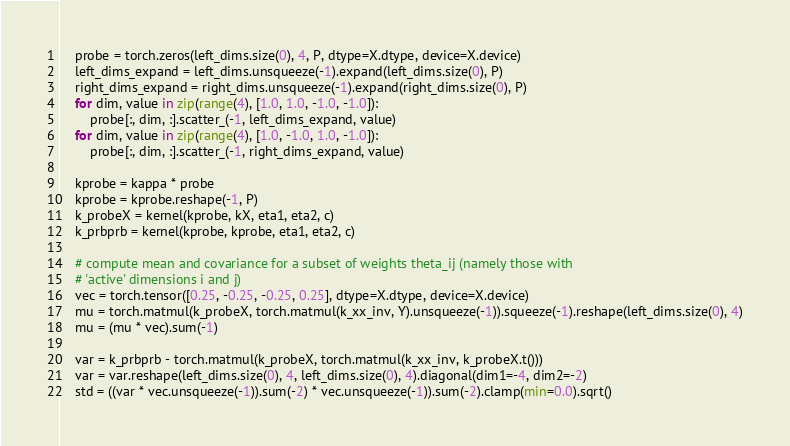Convert code to text. <code><loc_0><loc_0><loc_500><loc_500><_Python_>    probe = torch.zeros(left_dims.size(0), 4, P, dtype=X.dtype, device=X.device)
    left_dims_expand = left_dims.unsqueeze(-1).expand(left_dims.size(0), P)
    right_dims_expand = right_dims.unsqueeze(-1).expand(right_dims.size(0), P)
    for dim, value in zip(range(4), [1.0, 1.0, -1.0, -1.0]):
        probe[:, dim, :].scatter_(-1, left_dims_expand, value)
    for dim, value in zip(range(4), [1.0, -1.0, 1.0, -1.0]):
        probe[:, dim, :].scatter_(-1, right_dims_expand, value)

    kprobe = kappa * probe
    kprobe = kprobe.reshape(-1, P)
    k_probeX = kernel(kprobe, kX, eta1, eta2, c)
    k_prbprb = kernel(kprobe, kprobe, eta1, eta2, c)

    # compute mean and covariance for a subset of weights theta_ij (namely those with
    # 'active' dimensions i and j)
    vec = torch.tensor([0.25, -0.25, -0.25, 0.25], dtype=X.dtype, device=X.device)
    mu = torch.matmul(k_probeX, torch.matmul(k_xx_inv, Y).unsqueeze(-1)).squeeze(-1).reshape(left_dims.size(0), 4)
    mu = (mu * vec).sum(-1)

    var = k_prbprb - torch.matmul(k_probeX, torch.matmul(k_xx_inv, k_probeX.t()))
    var = var.reshape(left_dims.size(0), 4, left_dims.size(0), 4).diagonal(dim1=-4, dim2=-2)
    std = ((var * vec.unsqueeze(-1)).sum(-2) * vec.unsqueeze(-1)).sum(-2).clamp(min=0.0).sqrt()
</code> 